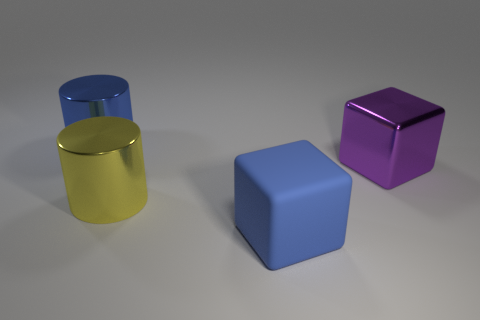Are there any yellow things that are behind the large cube behind the big blue matte thing?
Provide a short and direct response. No. Are there an equal number of big cylinders that are behind the yellow metal thing and big blue rubber cubes?
Make the answer very short. Yes. How many other objects are there of the same size as the purple cube?
Your response must be concise. 3. Are the large cube behind the blue rubber object and the big blue thing that is in front of the large purple metallic cube made of the same material?
Your response must be concise. No. How big is the matte object that is to the left of the cube behind the blue rubber cube?
Your answer should be very brief. Large. Are there any rubber cylinders of the same color as the rubber thing?
Make the answer very short. No. There is a big block that is right of the large blue rubber cube; is it the same color as the big thing that is in front of the yellow thing?
Make the answer very short. No. What is the shape of the large rubber thing?
Provide a short and direct response. Cube. There is a blue cube; how many large yellow cylinders are behind it?
Your answer should be compact. 1. How many large cylinders have the same material as the large purple thing?
Provide a succinct answer. 2. 